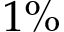<formula> <loc_0><loc_0><loc_500><loc_500>1 \%</formula> 